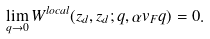<formula> <loc_0><loc_0><loc_500><loc_500>\lim _ { q \to 0 } W ^ { l o c a l } ( z _ { d } , z _ { d } ; q , \alpha v _ { F } q ) = 0 .</formula> 